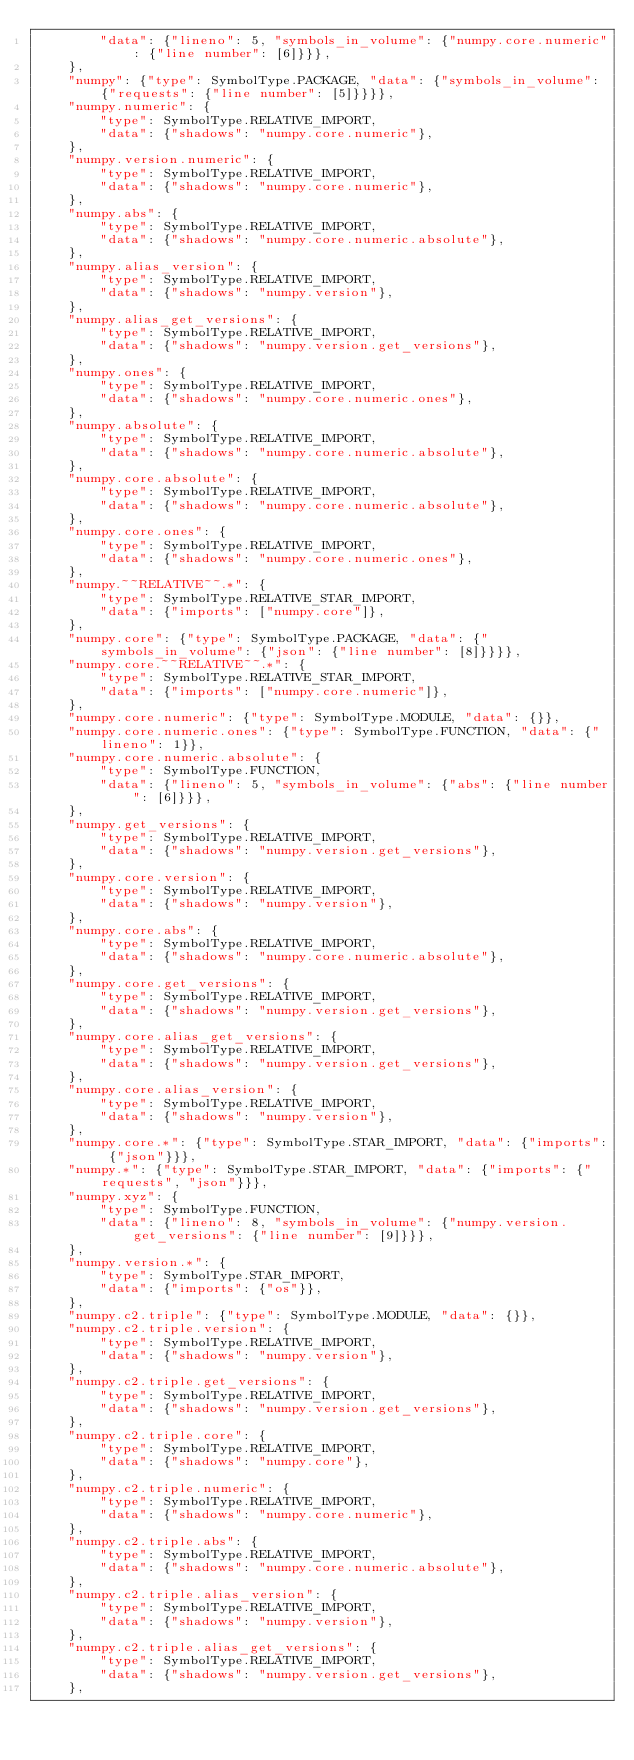Convert code to text. <code><loc_0><loc_0><loc_500><loc_500><_Python_>        "data": {"lineno": 5, "symbols_in_volume": {"numpy.core.numeric": {"line number": [6]}}},
    },
    "numpy": {"type": SymbolType.PACKAGE, "data": {"symbols_in_volume": {"requests": {"line number": [5]}}}},
    "numpy.numeric": {
        "type": SymbolType.RELATIVE_IMPORT,
        "data": {"shadows": "numpy.core.numeric"},
    },
    "numpy.version.numeric": {
        "type": SymbolType.RELATIVE_IMPORT,
        "data": {"shadows": "numpy.core.numeric"},
    },
    "numpy.abs": {
        "type": SymbolType.RELATIVE_IMPORT,
        "data": {"shadows": "numpy.core.numeric.absolute"},
    },
    "numpy.alias_version": {
        "type": SymbolType.RELATIVE_IMPORT,
        "data": {"shadows": "numpy.version"},
    },
    "numpy.alias_get_versions": {
        "type": SymbolType.RELATIVE_IMPORT,
        "data": {"shadows": "numpy.version.get_versions"},
    },
    "numpy.ones": {
        "type": SymbolType.RELATIVE_IMPORT,
        "data": {"shadows": "numpy.core.numeric.ones"},
    },
    "numpy.absolute": {
        "type": SymbolType.RELATIVE_IMPORT,
        "data": {"shadows": "numpy.core.numeric.absolute"},
    },
    "numpy.core.absolute": {
        "type": SymbolType.RELATIVE_IMPORT,
        "data": {"shadows": "numpy.core.numeric.absolute"},
    },
    "numpy.core.ones": {
        "type": SymbolType.RELATIVE_IMPORT,
        "data": {"shadows": "numpy.core.numeric.ones"},
    },
    "numpy.~~RELATIVE~~.*": {
        "type": SymbolType.RELATIVE_STAR_IMPORT,
        "data": {"imports": ["numpy.core"]},
    },
    "numpy.core": {"type": SymbolType.PACKAGE, "data": {"symbols_in_volume": {"json": {"line number": [8]}}}},
    "numpy.core.~~RELATIVE~~.*": {
        "type": SymbolType.RELATIVE_STAR_IMPORT,
        "data": {"imports": ["numpy.core.numeric"]},
    },
    "numpy.core.numeric": {"type": SymbolType.MODULE, "data": {}},
    "numpy.core.numeric.ones": {"type": SymbolType.FUNCTION, "data": {"lineno": 1}},
    "numpy.core.numeric.absolute": {
        "type": SymbolType.FUNCTION,
        "data": {"lineno": 5, "symbols_in_volume": {"abs": {"line number": [6]}}},
    },
    "numpy.get_versions": {
        "type": SymbolType.RELATIVE_IMPORT,
        "data": {"shadows": "numpy.version.get_versions"},
    },
    "numpy.core.version": {
        "type": SymbolType.RELATIVE_IMPORT,
        "data": {"shadows": "numpy.version"},
    },
    "numpy.core.abs": {
        "type": SymbolType.RELATIVE_IMPORT,
        "data": {"shadows": "numpy.core.numeric.absolute"},
    },
    "numpy.core.get_versions": {
        "type": SymbolType.RELATIVE_IMPORT,
        "data": {"shadows": "numpy.version.get_versions"},
    },
    "numpy.core.alias_get_versions": {
        "type": SymbolType.RELATIVE_IMPORT,
        "data": {"shadows": "numpy.version.get_versions"},
    },
    "numpy.core.alias_version": {
        "type": SymbolType.RELATIVE_IMPORT,
        "data": {"shadows": "numpy.version"},
    },
    "numpy.core.*": {"type": SymbolType.STAR_IMPORT, "data": {"imports": {"json"}}},
    "numpy.*": {"type": SymbolType.STAR_IMPORT, "data": {"imports": {"requests", "json"}}},
    "numpy.xyz": {
        "type": SymbolType.FUNCTION,
        "data": {"lineno": 8, "symbols_in_volume": {"numpy.version.get_versions": {"line number": [9]}}},
    },
    "numpy.version.*": {
        "type": SymbolType.STAR_IMPORT,
        "data": {"imports": {"os"}},
    },
    "numpy.c2.triple": {"type": SymbolType.MODULE, "data": {}},
    "numpy.c2.triple.version": {
        "type": SymbolType.RELATIVE_IMPORT,
        "data": {"shadows": "numpy.version"},
    },
    "numpy.c2.triple.get_versions": {
        "type": SymbolType.RELATIVE_IMPORT,
        "data": {"shadows": "numpy.version.get_versions"},
    },
    "numpy.c2.triple.core": {
        "type": SymbolType.RELATIVE_IMPORT,
        "data": {"shadows": "numpy.core"},
    },
    "numpy.c2.triple.numeric": {
        "type": SymbolType.RELATIVE_IMPORT,
        "data": {"shadows": "numpy.core.numeric"},
    },
    "numpy.c2.triple.abs": {
        "type": SymbolType.RELATIVE_IMPORT,
        "data": {"shadows": "numpy.core.numeric.absolute"},
    },
    "numpy.c2.triple.alias_version": {
        "type": SymbolType.RELATIVE_IMPORT,
        "data": {"shadows": "numpy.version"},
    },
    "numpy.c2.triple.alias_get_versions": {
        "type": SymbolType.RELATIVE_IMPORT,
        "data": {"shadows": "numpy.version.get_versions"},
    },</code> 